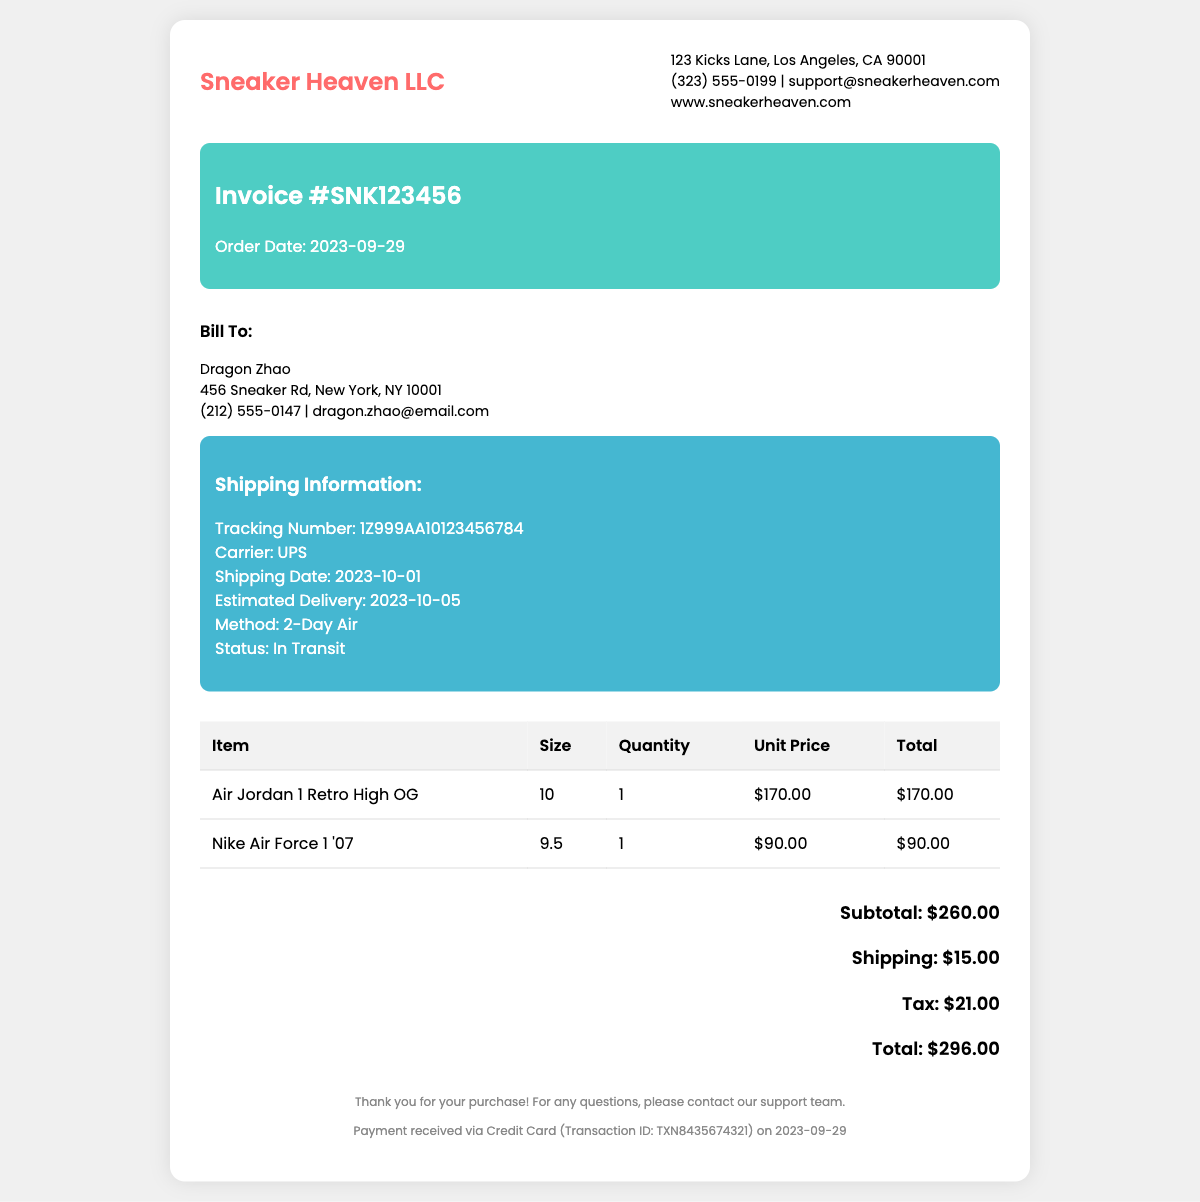What is the invoice number? The invoice number is prominently displayed under the invoice details section as Invoice #SNK123456.
Answer: SNK123456 Who is the customer? The customer's name is listed in the bill to section, where it mentions Dragon Zhao.
Answer: Dragon Zhao What is the total amount due? The total amount due can be found at the bottom of the invoice in the total section: Total: $296.00.
Answer: $296.00 What is the shipping carrier? The shipping carrier is specified in the shipping information section as UPS.
Answer: UPS When was the order placed? The order date is provided in the invoice details section marked as Order Date: 2023-09-29.
Answer: 2023-09-29 How much was the shipping charge? The shipping charge is listed in the total section and states Shipping: $15.00.
Answer: $15.00 What is the tracking number? The tracking number is included in the shipping information as Tracking Number: 1Z999AA10123456784.
Answer: 1Z999AA10123456784 What method was used for shipping? The shipping method is stated in the shipping information as 2-Day Air.
Answer: 2-Day Air When is the estimated delivery date? The estimated delivery date can be found in the shipping details as Estimated Delivery: 2023-10-05.
Answer: 2023-10-05 